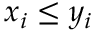<formula> <loc_0><loc_0><loc_500><loc_500>x _ { i } \leq y _ { i }</formula> 